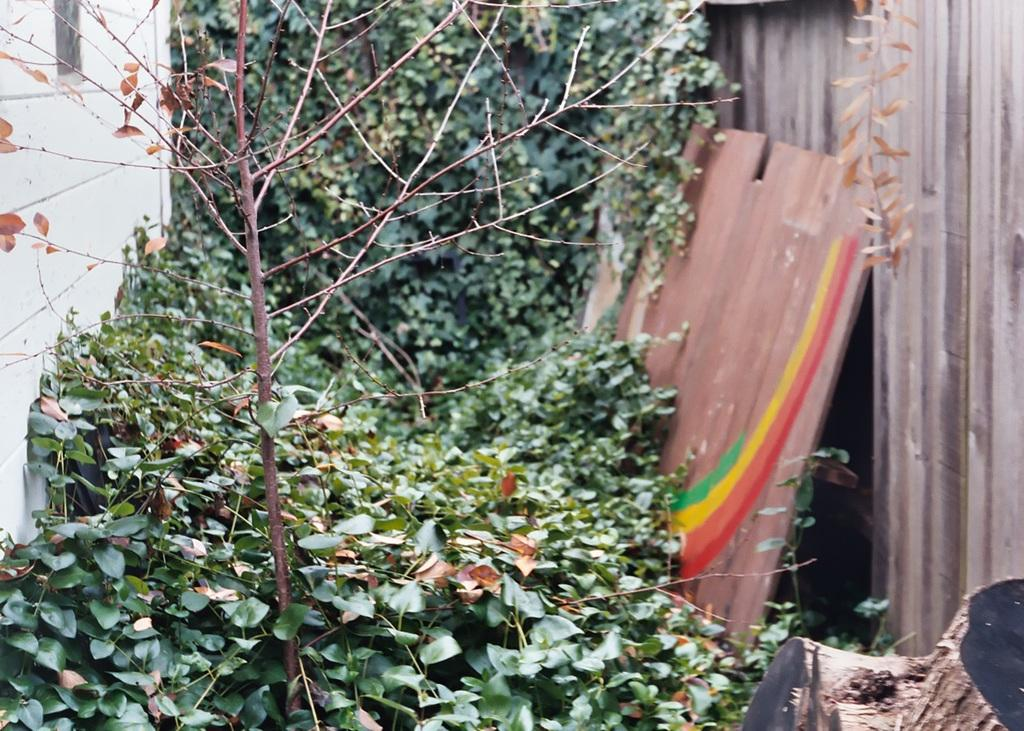What type of living organisms can be seen in the image? Plants can be seen in the image. What is located on the left side of the image? There is a wall on the left side of the image. What material are some of the objects made of in the image? There are wooden objects in the image. What is the large container-like object in the image? There is a trunk in the image. What type of screw can be seen holding the beds together in the image? There are no beds or screws present in the image. 